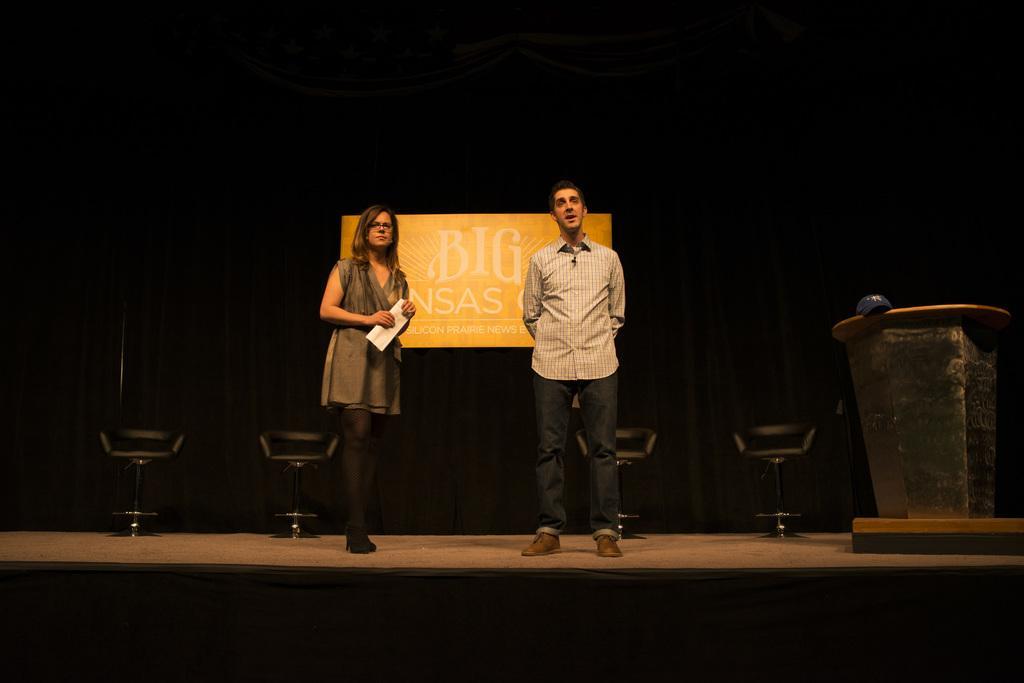Describe this image in one or two sentences. This picture is clicked inside. On the right there is a man wearing shirt and there is a woman wearing dress, holding an object and both of them are standing on the floor. On the right corner there is a cap placed on the top of the wooden podium. In the background we can see the chairs and the curtains and we can see a banner on which we can see the text is printed. 